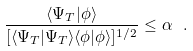Convert formula to latex. <formula><loc_0><loc_0><loc_500><loc_500>\frac { \langle \Psi _ { T } | \phi \rangle } { [ \langle \Psi _ { T } | \Psi _ { T } \rangle \langle \phi | \phi \rangle ] ^ { 1 / 2 } } \leq \alpha \ .</formula> 